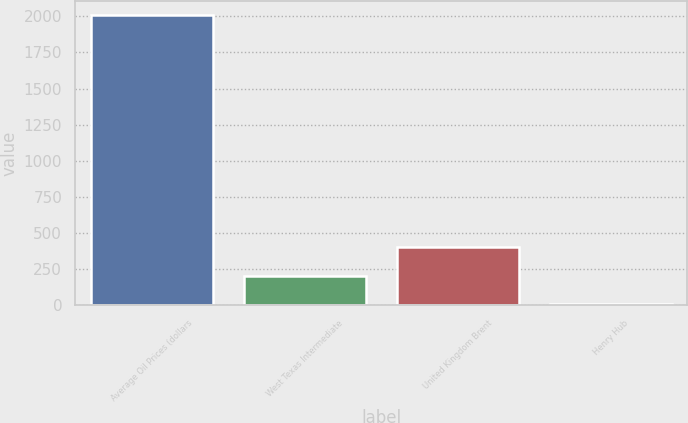Convert chart. <chart><loc_0><loc_0><loc_500><loc_500><bar_chart><fcel>Average Oil Prices (dollars<fcel>West Texas Intermediate<fcel>United Kingdom Brent<fcel>Henry Hub<nl><fcel>2007<fcel>207.16<fcel>407.14<fcel>7.18<nl></chart> 